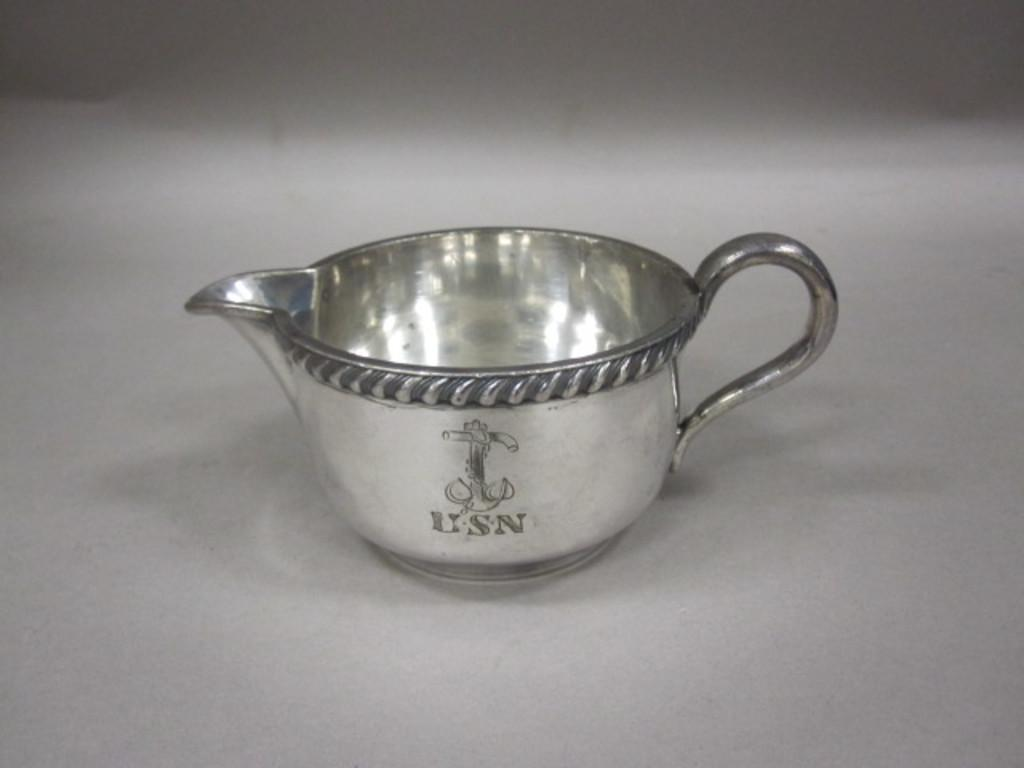<image>
Create a compact narrative representing the image presented. a small silver cup that says 'usn' on it 